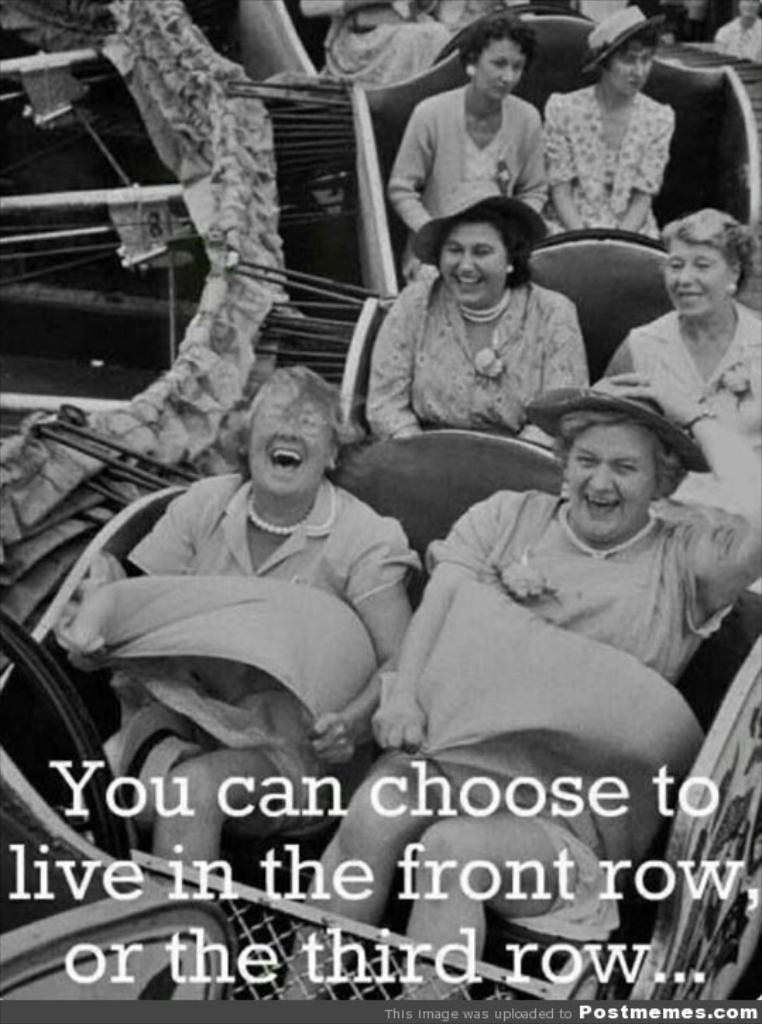What is the main subject of the image? The main subject of the image is a group of people. What is the color scheme of the image? The image is in black and white. Are there any words or letters visible in the image? Yes, there is text visible on the image. Can you describe the patch of grass in the image? There is no patch of grass present in the image. What type of shock can be seen affecting the people in the image? There is no shock or any indication of a shock in the image; it features a group of people and text. 